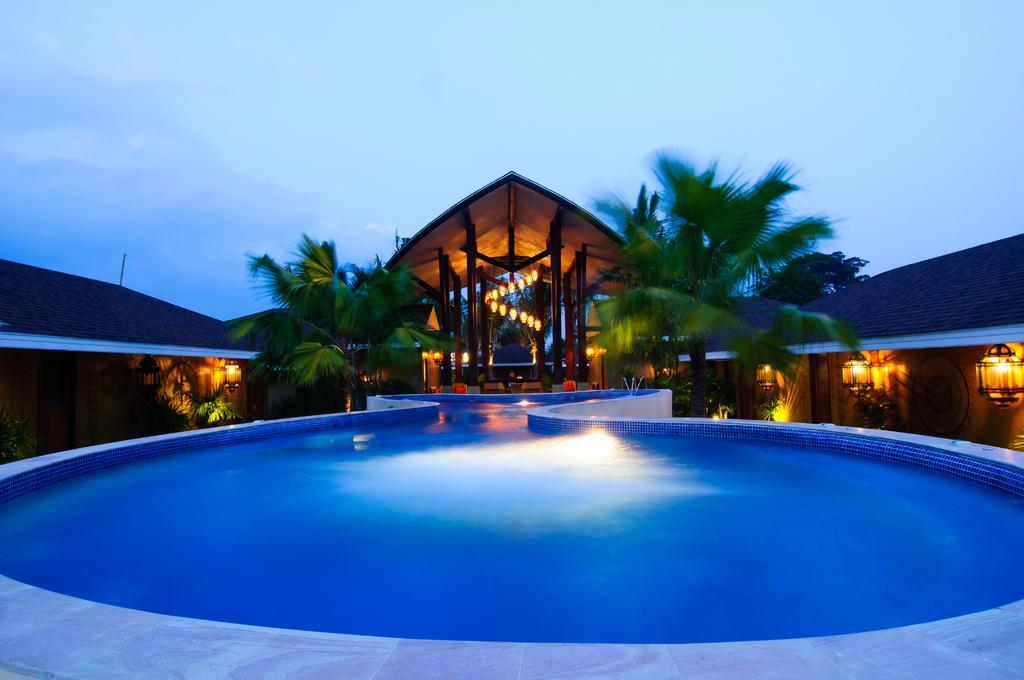Could you give a brief overview of what you see in this image? In this image, we can see a house and there are lights, trees and lamps. At the top, there is sky and at the bottom, there is water. 